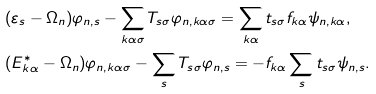<formula> <loc_0><loc_0><loc_500><loc_500>& ( \varepsilon _ { s } - \Omega _ { n } ) \varphi _ { n , s } - \sum _ { k \alpha \sigma } T _ { s \sigma } \varphi _ { n , k \alpha \sigma } = \sum _ { k \alpha } t _ { s \sigma } f _ { k \alpha } \psi _ { n , k \alpha } , \\ & ( E ^ { * } _ { k \alpha } - \Omega _ { n } ) \varphi _ { n , k \alpha \sigma } - \sum _ { s } T _ { s \sigma } \varphi _ { n , s } = - f _ { k \alpha } \sum _ { s } t _ { s \sigma } \psi _ { n , s } .</formula> 